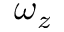Convert formula to latex. <formula><loc_0><loc_0><loc_500><loc_500>\omega _ { z }</formula> 